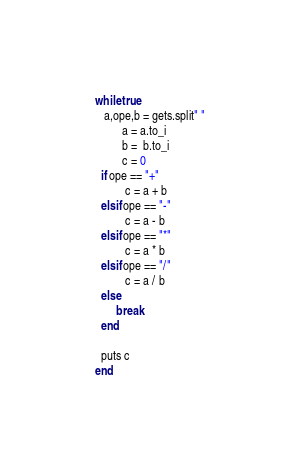<code> <loc_0><loc_0><loc_500><loc_500><_Ruby_>while true
   a,ope,b = gets.split" "
         a = a.to_i
         b =  b.to_i
         c = 0
  if ope == "+"
          c = a + b 
  elsif ope == "-"      
          c = a - b
  elsif ope == "*"
          c = a * b
  elsif ope == "/"
          c = a / b
  else
       break
  end
  
  puts c
end</code> 